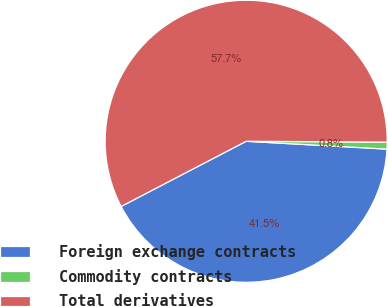Convert chart to OTSL. <chart><loc_0><loc_0><loc_500><loc_500><pie_chart><fcel>Foreign exchange contracts<fcel>Commodity contracts<fcel>Total derivatives<nl><fcel>41.47%<fcel>0.79%<fcel>57.74%<nl></chart> 